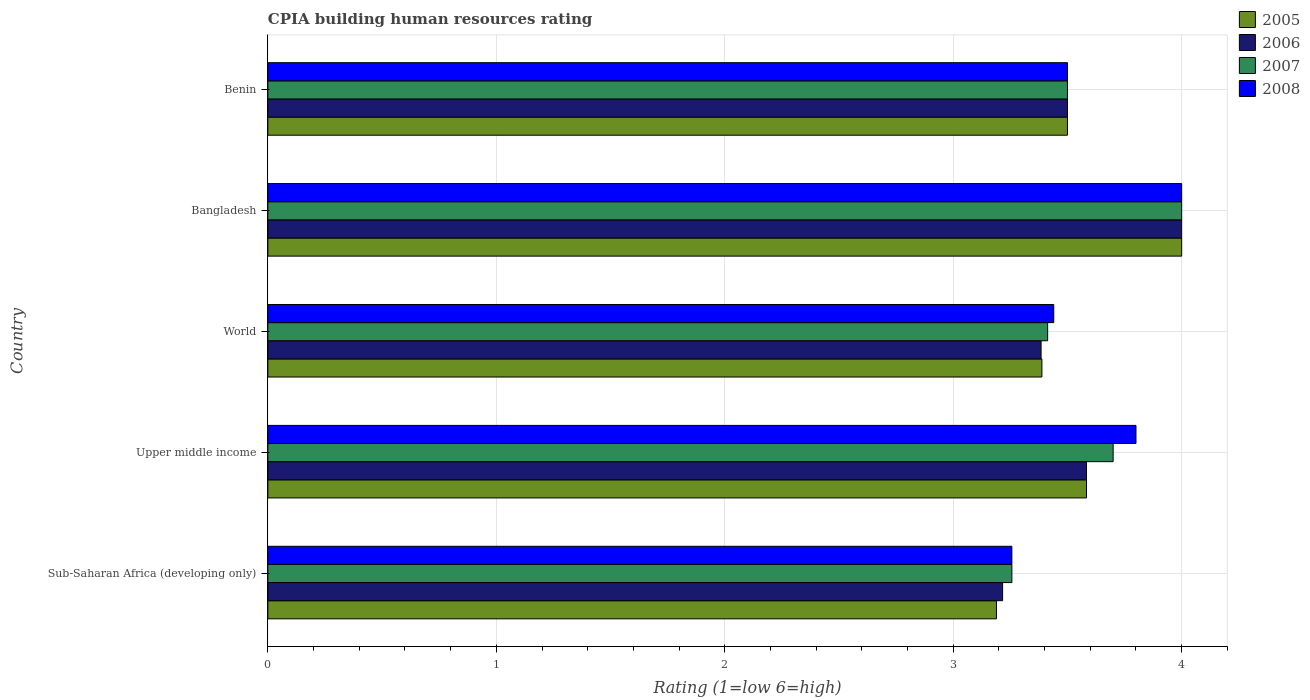How many different coloured bars are there?
Offer a terse response. 4. How many bars are there on the 4th tick from the bottom?
Your answer should be compact. 4. What is the label of the 1st group of bars from the top?
Your answer should be very brief. Benin. In how many cases, is the number of bars for a given country not equal to the number of legend labels?
Your response must be concise. 0. What is the CPIA rating in 2007 in Benin?
Offer a very short reply. 3.5. Across all countries, what is the minimum CPIA rating in 2005?
Keep it short and to the point. 3.19. In which country was the CPIA rating in 2005 maximum?
Your answer should be very brief. Bangladesh. In which country was the CPIA rating in 2008 minimum?
Your response must be concise. Sub-Saharan Africa (developing only). What is the total CPIA rating in 2006 in the graph?
Your answer should be compact. 17.68. What is the difference between the CPIA rating in 2006 in Sub-Saharan Africa (developing only) and that in Upper middle income?
Ensure brevity in your answer.  -0.37. What is the difference between the CPIA rating in 2008 in Bangladesh and the CPIA rating in 2006 in World?
Your answer should be compact. 0.62. What is the average CPIA rating in 2005 per country?
Keep it short and to the point. 3.53. What is the difference between the CPIA rating in 2005 and CPIA rating in 2006 in World?
Provide a succinct answer. 0. In how many countries, is the CPIA rating in 2006 greater than 2.8 ?
Ensure brevity in your answer.  5. What is the ratio of the CPIA rating in 2005 in Sub-Saharan Africa (developing only) to that in Upper middle income?
Your answer should be very brief. 0.89. Is the CPIA rating in 2005 in Benin less than that in Upper middle income?
Ensure brevity in your answer.  Yes. Is the difference between the CPIA rating in 2005 in Bangladesh and Benin greater than the difference between the CPIA rating in 2006 in Bangladesh and Benin?
Your answer should be very brief. No. What is the difference between the highest and the second highest CPIA rating in 2006?
Make the answer very short. 0.42. What is the difference between the highest and the lowest CPIA rating in 2007?
Offer a very short reply. 0.74. In how many countries, is the CPIA rating in 2005 greater than the average CPIA rating in 2005 taken over all countries?
Offer a very short reply. 2. Is the sum of the CPIA rating in 2005 in Bangladesh and Benin greater than the maximum CPIA rating in 2008 across all countries?
Give a very brief answer. Yes. Is it the case that in every country, the sum of the CPIA rating in 2005 and CPIA rating in 2006 is greater than the sum of CPIA rating in 2007 and CPIA rating in 2008?
Offer a terse response. No. What does the 4th bar from the bottom in Upper middle income represents?
Your answer should be very brief. 2008. What is the difference between two consecutive major ticks on the X-axis?
Ensure brevity in your answer.  1. Where does the legend appear in the graph?
Keep it short and to the point. Top right. How many legend labels are there?
Give a very brief answer. 4. How are the legend labels stacked?
Offer a terse response. Vertical. What is the title of the graph?
Provide a short and direct response. CPIA building human resources rating. Does "2013" appear as one of the legend labels in the graph?
Give a very brief answer. No. What is the label or title of the Y-axis?
Ensure brevity in your answer.  Country. What is the Rating (1=low 6=high) of 2005 in Sub-Saharan Africa (developing only)?
Your response must be concise. 3.19. What is the Rating (1=low 6=high) of 2006 in Sub-Saharan Africa (developing only)?
Keep it short and to the point. 3.22. What is the Rating (1=low 6=high) in 2007 in Sub-Saharan Africa (developing only)?
Your answer should be very brief. 3.26. What is the Rating (1=low 6=high) in 2008 in Sub-Saharan Africa (developing only)?
Provide a short and direct response. 3.26. What is the Rating (1=low 6=high) in 2005 in Upper middle income?
Ensure brevity in your answer.  3.58. What is the Rating (1=low 6=high) in 2006 in Upper middle income?
Ensure brevity in your answer.  3.58. What is the Rating (1=low 6=high) in 2007 in Upper middle income?
Ensure brevity in your answer.  3.7. What is the Rating (1=low 6=high) of 2008 in Upper middle income?
Your answer should be very brief. 3.8. What is the Rating (1=low 6=high) of 2005 in World?
Offer a very short reply. 3.39. What is the Rating (1=low 6=high) in 2006 in World?
Keep it short and to the point. 3.38. What is the Rating (1=low 6=high) of 2007 in World?
Offer a terse response. 3.41. What is the Rating (1=low 6=high) in 2008 in World?
Provide a short and direct response. 3.44. What is the Rating (1=low 6=high) in 2006 in Bangladesh?
Offer a very short reply. 4. What is the Rating (1=low 6=high) of 2007 in Bangladesh?
Your answer should be compact. 4. What is the Rating (1=low 6=high) in 2007 in Benin?
Your answer should be very brief. 3.5. What is the Rating (1=low 6=high) of 2008 in Benin?
Offer a terse response. 3.5. Across all countries, what is the maximum Rating (1=low 6=high) in 2006?
Your answer should be compact. 4. Across all countries, what is the maximum Rating (1=low 6=high) in 2007?
Your answer should be very brief. 4. Across all countries, what is the minimum Rating (1=low 6=high) in 2005?
Your answer should be compact. 3.19. Across all countries, what is the minimum Rating (1=low 6=high) in 2006?
Offer a very short reply. 3.22. Across all countries, what is the minimum Rating (1=low 6=high) in 2007?
Your answer should be compact. 3.26. Across all countries, what is the minimum Rating (1=low 6=high) of 2008?
Your answer should be very brief. 3.26. What is the total Rating (1=low 6=high) in 2005 in the graph?
Your answer should be very brief. 17.66. What is the total Rating (1=low 6=high) in 2006 in the graph?
Your answer should be very brief. 17.68. What is the total Rating (1=low 6=high) in 2007 in the graph?
Give a very brief answer. 17.87. What is the total Rating (1=low 6=high) of 2008 in the graph?
Give a very brief answer. 18. What is the difference between the Rating (1=low 6=high) in 2005 in Sub-Saharan Africa (developing only) and that in Upper middle income?
Your response must be concise. -0.39. What is the difference between the Rating (1=low 6=high) in 2006 in Sub-Saharan Africa (developing only) and that in Upper middle income?
Ensure brevity in your answer.  -0.37. What is the difference between the Rating (1=low 6=high) of 2007 in Sub-Saharan Africa (developing only) and that in Upper middle income?
Give a very brief answer. -0.44. What is the difference between the Rating (1=low 6=high) in 2008 in Sub-Saharan Africa (developing only) and that in Upper middle income?
Provide a short and direct response. -0.54. What is the difference between the Rating (1=low 6=high) of 2005 in Sub-Saharan Africa (developing only) and that in World?
Keep it short and to the point. -0.2. What is the difference between the Rating (1=low 6=high) in 2006 in Sub-Saharan Africa (developing only) and that in World?
Give a very brief answer. -0.17. What is the difference between the Rating (1=low 6=high) in 2007 in Sub-Saharan Africa (developing only) and that in World?
Make the answer very short. -0.16. What is the difference between the Rating (1=low 6=high) in 2008 in Sub-Saharan Africa (developing only) and that in World?
Offer a very short reply. -0.18. What is the difference between the Rating (1=low 6=high) of 2005 in Sub-Saharan Africa (developing only) and that in Bangladesh?
Make the answer very short. -0.81. What is the difference between the Rating (1=low 6=high) of 2006 in Sub-Saharan Africa (developing only) and that in Bangladesh?
Keep it short and to the point. -0.78. What is the difference between the Rating (1=low 6=high) of 2007 in Sub-Saharan Africa (developing only) and that in Bangladesh?
Your answer should be compact. -0.74. What is the difference between the Rating (1=low 6=high) in 2008 in Sub-Saharan Africa (developing only) and that in Bangladesh?
Provide a succinct answer. -0.74. What is the difference between the Rating (1=low 6=high) in 2005 in Sub-Saharan Africa (developing only) and that in Benin?
Offer a very short reply. -0.31. What is the difference between the Rating (1=low 6=high) of 2006 in Sub-Saharan Africa (developing only) and that in Benin?
Offer a very short reply. -0.28. What is the difference between the Rating (1=low 6=high) in 2007 in Sub-Saharan Africa (developing only) and that in Benin?
Your response must be concise. -0.24. What is the difference between the Rating (1=low 6=high) of 2008 in Sub-Saharan Africa (developing only) and that in Benin?
Your answer should be very brief. -0.24. What is the difference between the Rating (1=low 6=high) in 2005 in Upper middle income and that in World?
Your answer should be compact. 0.2. What is the difference between the Rating (1=low 6=high) of 2006 in Upper middle income and that in World?
Make the answer very short. 0.2. What is the difference between the Rating (1=low 6=high) of 2007 in Upper middle income and that in World?
Keep it short and to the point. 0.29. What is the difference between the Rating (1=low 6=high) in 2008 in Upper middle income and that in World?
Offer a terse response. 0.36. What is the difference between the Rating (1=low 6=high) of 2005 in Upper middle income and that in Bangladesh?
Offer a terse response. -0.42. What is the difference between the Rating (1=low 6=high) of 2006 in Upper middle income and that in Bangladesh?
Offer a very short reply. -0.42. What is the difference between the Rating (1=low 6=high) in 2008 in Upper middle income and that in Bangladesh?
Your answer should be very brief. -0.2. What is the difference between the Rating (1=low 6=high) in 2005 in Upper middle income and that in Benin?
Provide a short and direct response. 0.08. What is the difference between the Rating (1=low 6=high) in 2006 in Upper middle income and that in Benin?
Provide a short and direct response. 0.08. What is the difference between the Rating (1=low 6=high) in 2007 in Upper middle income and that in Benin?
Make the answer very short. 0.2. What is the difference between the Rating (1=low 6=high) in 2005 in World and that in Bangladesh?
Provide a short and direct response. -0.61. What is the difference between the Rating (1=low 6=high) of 2006 in World and that in Bangladesh?
Provide a short and direct response. -0.62. What is the difference between the Rating (1=low 6=high) in 2007 in World and that in Bangladesh?
Your answer should be compact. -0.59. What is the difference between the Rating (1=low 6=high) of 2008 in World and that in Bangladesh?
Your response must be concise. -0.56. What is the difference between the Rating (1=low 6=high) in 2005 in World and that in Benin?
Make the answer very short. -0.11. What is the difference between the Rating (1=low 6=high) of 2006 in World and that in Benin?
Your answer should be very brief. -0.12. What is the difference between the Rating (1=low 6=high) in 2007 in World and that in Benin?
Make the answer very short. -0.09. What is the difference between the Rating (1=low 6=high) of 2008 in World and that in Benin?
Offer a very short reply. -0.06. What is the difference between the Rating (1=low 6=high) of 2005 in Bangladesh and that in Benin?
Offer a terse response. 0.5. What is the difference between the Rating (1=low 6=high) in 2007 in Bangladesh and that in Benin?
Your answer should be very brief. 0.5. What is the difference between the Rating (1=low 6=high) of 2005 in Sub-Saharan Africa (developing only) and the Rating (1=low 6=high) of 2006 in Upper middle income?
Your response must be concise. -0.39. What is the difference between the Rating (1=low 6=high) in 2005 in Sub-Saharan Africa (developing only) and the Rating (1=low 6=high) in 2007 in Upper middle income?
Keep it short and to the point. -0.51. What is the difference between the Rating (1=low 6=high) in 2005 in Sub-Saharan Africa (developing only) and the Rating (1=low 6=high) in 2008 in Upper middle income?
Provide a succinct answer. -0.61. What is the difference between the Rating (1=low 6=high) in 2006 in Sub-Saharan Africa (developing only) and the Rating (1=low 6=high) in 2007 in Upper middle income?
Provide a short and direct response. -0.48. What is the difference between the Rating (1=low 6=high) in 2006 in Sub-Saharan Africa (developing only) and the Rating (1=low 6=high) in 2008 in Upper middle income?
Keep it short and to the point. -0.58. What is the difference between the Rating (1=low 6=high) in 2007 in Sub-Saharan Africa (developing only) and the Rating (1=low 6=high) in 2008 in Upper middle income?
Offer a very short reply. -0.54. What is the difference between the Rating (1=low 6=high) in 2005 in Sub-Saharan Africa (developing only) and the Rating (1=low 6=high) in 2006 in World?
Your answer should be compact. -0.2. What is the difference between the Rating (1=low 6=high) of 2005 in Sub-Saharan Africa (developing only) and the Rating (1=low 6=high) of 2007 in World?
Your answer should be very brief. -0.22. What is the difference between the Rating (1=low 6=high) in 2005 in Sub-Saharan Africa (developing only) and the Rating (1=low 6=high) in 2008 in World?
Provide a succinct answer. -0.25. What is the difference between the Rating (1=low 6=high) of 2006 in Sub-Saharan Africa (developing only) and the Rating (1=low 6=high) of 2007 in World?
Provide a short and direct response. -0.2. What is the difference between the Rating (1=low 6=high) of 2006 in Sub-Saharan Africa (developing only) and the Rating (1=low 6=high) of 2008 in World?
Your answer should be compact. -0.22. What is the difference between the Rating (1=low 6=high) in 2007 in Sub-Saharan Africa (developing only) and the Rating (1=low 6=high) in 2008 in World?
Provide a short and direct response. -0.18. What is the difference between the Rating (1=low 6=high) in 2005 in Sub-Saharan Africa (developing only) and the Rating (1=low 6=high) in 2006 in Bangladesh?
Offer a very short reply. -0.81. What is the difference between the Rating (1=low 6=high) in 2005 in Sub-Saharan Africa (developing only) and the Rating (1=low 6=high) in 2007 in Bangladesh?
Offer a terse response. -0.81. What is the difference between the Rating (1=low 6=high) of 2005 in Sub-Saharan Africa (developing only) and the Rating (1=low 6=high) of 2008 in Bangladesh?
Provide a succinct answer. -0.81. What is the difference between the Rating (1=low 6=high) of 2006 in Sub-Saharan Africa (developing only) and the Rating (1=low 6=high) of 2007 in Bangladesh?
Your answer should be compact. -0.78. What is the difference between the Rating (1=low 6=high) in 2006 in Sub-Saharan Africa (developing only) and the Rating (1=low 6=high) in 2008 in Bangladesh?
Give a very brief answer. -0.78. What is the difference between the Rating (1=low 6=high) in 2007 in Sub-Saharan Africa (developing only) and the Rating (1=low 6=high) in 2008 in Bangladesh?
Provide a succinct answer. -0.74. What is the difference between the Rating (1=low 6=high) in 2005 in Sub-Saharan Africa (developing only) and the Rating (1=low 6=high) in 2006 in Benin?
Ensure brevity in your answer.  -0.31. What is the difference between the Rating (1=low 6=high) of 2005 in Sub-Saharan Africa (developing only) and the Rating (1=low 6=high) of 2007 in Benin?
Your response must be concise. -0.31. What is the difference between the Rating (1=low 6=high) of 2005 in Sub-Saharan Africa (developing only) and the Rating (1=low 6=high) of 2008 in Benin?
Provide a short and direct response. -0.31. What is the difference between the Rating (1=low 6=high) in 2006 in Sub-Saharan Africa (developing only) and the Rating (1=low 6=high) in 2007 in Benin?
Offer a very short reply. -0.28. What is the difference between the Rating (1=low 6=high) in 2006 in Sub-Saharan Africa (developing only) and the Rating (1=low 6=high) in 2008 in Benin?
Make the answer very short. -0.28. What is the difference between the Rating (1=low 6=high) in 2007 in Sub-Saharan Africa (developing only) and the Rating (1=low 6=high) in 2008 in Benin?
Ensure brevity in your answer.  -0.24. What is the difference between the Rating (1=low 6=high) in 2005 in Upper middle income and the Rating (1=low 6=high) in 2006 in World?
Provide a short and direct response. 0.2. What is the difference between the Rating (1=low 6=high) in 2005 in Upper middle income and the Rating (1=low 6=high) in 2007 in World?
Provide a short and direct response. 0.17. What is the difference between the Rating (1=low 6=high) of 2005 in Upper middle income and the Rating (1=low 6=high) of 2008 in World?
Offer a terse response. 0.14. What is the difference between the Rating (1=low 6=high) in 2006 in Upper middle income and the Rating (1=low 6=high) in 2007 in World?
Offer a terse response. 0.17. What is the difference between the Rating (1=low 6=high) in 2006 in Upper middle income and the Rating (1=low 6=high) in 2008 in World?
Ensure brevity in your answer.  0.14. What is the difference between the Rating (1=low 6=high) of 2007 in Upper middle income and the Rating (1=low 6=high) of 2008 in World?
Provide a succinct answer. 0.26. What is the difference between the Rating (1=low 6=high) of 2005 in Upper middle income and the Rating (1=low 6=high) of 2006 in Bangladesh?
Your response must be concise. -0.42. What is the difference between the Rating (1=low 6=high) in 2005 in Upper middle income and the Rating (1=low 6=high) in 2007 in Bangladesh?
Your answer should be very brief. -0.42. What is the difference between the Rating (1=low 6=high) in 2005 in Upper middle income and the Rating (1=low 6=high) in 2008 in Bangladesh?
Your response must be concise. -0.42. What is the difference between the Rating (1=low 6=high) of 2006 in Upper middle income and the Rating (1=low 6=high) of 2007 in Bangladesh?
Your response must be concise. -0.42. What is the difference between the Rating (1=low 6=high) in 2006 in Upper middle income and the Rating (1=low 6=high) in 2008 in Bangladesh?
Keep it short and to the point. -0.42. What is the difference between the Rating (1=low 6=high) in 2007 in Upper middle income and the Rating (1=low 6=high) in 2008 in Bangladesh?
Your response must be concise. -0.3. What is the difference between the Rating (1=low 6=high) of 2005 in Upper middle income and the Rating (1=low 6=high) of 2006 in Benin?
Your answer should be compact. 0.08. What is the difference between the Rating (1=low 6=high) of 2005 in Upper middle income and the Rating (1=low 6=high) of 2007 in Benin?
Give a very brief answer. 0.08. What is the difference between the Rating (1=low 6=high) of 2005 in Upper middle income and the Rating (1=low 6=high) of 2008 in Benin?
Offer a very short reply. 0.08. What is the difference between the Rating (1=low 6=high) of 2006 in Upper middle income and the Rating (1=low 6=high) of 2007 in Benin?
Your answer should be very brief. 0.08. What is the difference between the Rating (1=low 6=high) in 2006 in Upper middle income and the Rating (1=low 6=high) in 2008 in Benin?
Provide a succinct answer. 0.08. What is the difference between the Rating (1=low 6=high) in 2005 in World and the Rating (1=low 6=high) in 2006 in Bangladesh?
Your answer should be compact. -0.61. What is the difference between the Rating (1=low 6=high) in 2005 in World and the Rating (1=low 6=high) in 2007 in Bangladesh?
Offer a terse response. -0.61. What is the difference between the Rating (1=low 6=high) of 2005 in World and the Rating (1=low 6=high) of 2008 in Bangladesh?
Provide a short and direct response. -0.61. What is the difference between the Rating (1=low 6=high) of 2006 in World and the Rating (1=low 6=high) of 2007 in Bangladesh?
Provide a succinct answer. -0.62. What is the difference between the Rating (1=low 6=high) in 2006 in World and the Rating (1=low 6=high) in 2008 in Bangladesh?
Provide a short and direct response. -0.62. What is the difference between the Rating (1=low 6=high) in 2007 in World and the Rating (1=low 6=high) in 2008 in Bangladesh?
Keep it short and to the point. -0.59. What is the difference between the Rating (1=low 6=high) of 2005 in World and the Rating (1=low 6=high) of 2006 in Benin?
Your answer should be compact. -0.11. What is the difference between the Rating (1=low 6=high) of 2005 in World and the Rating (1=low 6=high) of 2007 in Benin?
Your response must be concise. -0.11. What is the difference between the Rating (1=low 6=high) of 2005 in World and the Rating (1=low 6=high) of 2008 in Benin?
Offer a very short reply. -0.11. What is the difference between the Rating (1=low 6=high) in 2006 in World and the Rating (1=low 6=high) in 2007 in Benin?
Your answer should be compact. -0.12. What is the difference between the Rating (1=low 6=high) of 2006 in World and the Rating (1=low 6=high) of 2008 in Benin?
Your answer should be very brief. -0.12. What is the difference between the Rating (1=low 6=high) in 2007 in World and the Rating (1=low 6=high) in 2008 in Benin?
Offer a terse response. -0.09. What is the difference between the Rating (1=low 6=high) of 2005 in Bangladesh and the Rating (1=low 6=high) of 2006 in Benin?
Provide a succinct answer. 0.5. What is the difference between the Rating (1=low 6=high) of 2005 in Bangladesh and the Rating (1=low 6=high) of 2007 in Benin?
Your answer should be compact. 0.5. What is the difference between the Rating (1=low 6=high) of 2006 in Bangladesh and the Rating (1=low 6=high) of 2008 in Benin?
Make the answer very short. 0.5. What is the average Rating (1=low 6=high) of 2005 per country?
Ensure brevity in your answer.  3.53. What is the average Rating (1=low 6=high) in 2006 per country?
Ensure brevity in your answer.  3.54. What is the average Rating (1=low 6=high) of 2007 per country?
Your answer should be compact. 3.57. What is the average Rating (1=low 6=high) of 2008 per country?
Your answer should be very brief. 3.6. What is the difference between the Rating (1=low 6=high) of 2005 and Rating (1=low 6=high) of 2006 in Sub-Saharan Africa (developing only)?
Make the answer very short. -0.03. What is the difference between the Rating (1=low 6=high) in 2005 and Rating (1=low 6=high) in 2007 in Sub-Saharan Africa (developing only)?
Provide a succinct answer. -0.07. What is the difference between the Rating (1=low 6=high) of 2005 and Rating (1=low 6=high) of 2008 in Sub-Saharan Africa (developing only)?
Keep it short and to the point. -0.07. What is the difference between the Rating (1=low 6=high) in 2006 and Rating (1=low 6=high) in 2007 in Sub-Saharan Africa (developing only)?
Make the answer very short. -0.04. What is the difference between the Rating (1=low 6=high) in 2006 and Rating (1=low 6=high) in 2008 in Sub-Saharan Africa (developing only)?
Ensure brevity in your answer.  -0.04. What is the difference between the Rating (1=low 6=high) in 2005 and Rating (1=low 6=high) in 2007 in Upper middle income?
Keep it short and to the point. -0.12. What is the difference between the Rating (1=low 6=high) in 2005 and Rating (1=low 6=high) in 2008 in Upper middle income?
Provide a succinct answer. -0.22. What is the difference between the Rating (1=low 6=high) of 2006 and Rating (1=low 6=high) of 2007 in Upper middle income?
Offer a very short reply. -0.12. What is the difference between the Rating (1=low 6=high) in 2006 and Rating (1=low 6=high) in 2008 in Upper middle income?
Offer a terse response. -0.22. What is the difference between the Rating (1=low 6=high) of 2007 and Rating (1=low 6=high) of 2008 in Upper middle income?
Make the answer very short. -0.1. What is the difference between the Rating (1=low 6=high) of 2005 and Rating (1=low 6=high) of 2006 in World?
Keep it short and to the point. 0. What is the difference between the Rating (1=low 6=high) of 2005 and Rating (1=low 6=high) of 2007 in World?
Keep it short and to the point. -0.03. What is the difference between the Rating (1=low 6=high) in 2005 and Rating (1=low 6=high) in 2008 in World?
Provide a short and direct response. -0.05. What is the difference between the Rating (1=low 6=high) of 2006 and Rating (1=low 6=high) of 2007 in World?
Ensure brevity in your answer.  -0.03. What is the difference between the Rating (1=low 6=high) of 2006 and Rating (1=low 6=high) of 2008 in World?
Your answer should be compact. -0.06. What is the difference between the Rating (1=low 6=high) of 2007 and Rating (1=low 6=high) of 2008 in World?
Provide a short and direct response. -0.03. What is the difference between the Rating (1=low 6=high) of 2005 and Rating (1=low 6=high) of 2008 in Bangladesh?
Provide a succinct answer. 0. What is the difference between the Rating (1=low 6=high) of 2006 and Rating (1=low 6=high) of 2007 in Bangladesh?
Your response must be concise. 0. What is the difference between the Rating (1=low 6=high) of 2005 and Rating (1=low 6=high) of 2006 in Benin?
Ensure brevity in your answer.  0. What is the difference between the Rating (1=low 6=high) of 2005 and Rating (1=low 6=high) of 2007 in Benin?
Ensure brevity in your answer.  0. What is the difference between the Rating (1=low 6=high) of 2007 and Rating (1=low 6=high) of 2008 in Benin?
Your answer should be compact. 0. What is the ratio of the Rating (1=low 6=high) of 2005 in Sub-Saharan Africa (developing only) to that in Upper middle income?
Your response must be concise. 0.89. What is the ratio of the Rating (1=low 6=high) in 2006 in Sub-Saharan Africa (developing only) to that in Upper middle income?
Make the answer very short. 0.9. What is the ratio of the Rating (1=low 6=high) in 2007 in Sub-Saharan Africa (developing only) to that in Upper middle income?
Provide a short and direct response. 0.88. What is the ratio of the Rating (1=low 6=high) in 2008 in Sub-Saharan Africa (developing only) to that in Upper middle income?
Offer a terse response. 0.86. What is the ratio of the Rating (1=low 6=high) in 2005 in Sub-Saharan Africa (developing only) to that in World?
Your response must be concise. 0.94. What is the ratio of the Rating (1=low 6=high) in 2006 in Sub-Saharan Africa (developing only) to that in World?
Offer a terse response. 0.95. What is the ratio of the Rating (1=low 6=high) in 2007 in Sub-Saharan Africa (developing only) to that in World?
Give a very brief answer. 0.95. What is the ratio of the Rating (1=low 6=high) in 2008 in Sub-Saharan Africa (developing only) to that in World?
Offer a very short reply. 0.95. What is the ratio of the Rating (1=low 6=high) of 2005 in Sub-Saharan Africa (developing only) to that in Bangladesh?
Offer a very short reply. 0.8. What is the ratio of the Rating (1=low 6=high) of 2006 in Sub-Saharan Africa (developing only) to that in Bangladesh?
Offer a terse response. 0.8. What is the ratio of the Rating (1=low 6=high) in 2007 in Sub-Saharan Africa (developing only) to that in Bangladesh?
Offer a terse response. 0.81. What is the ratio of the Rating (1=low 6=high) of 2008 in Sub-Saharan Africa (developing only) to that in Bangladesh?
Give a very brief answer. 0.81. What is the ratio of the Rating (1=low 6=high) in 2005 in Sub-Saharan Africa (developing only) to that in Benin?
Ensure brevity in your answer.  0.91. What is the ratio of the Rating (1=low 6=high) of 2006 in Sub-Saharan Africa (developing only) to that in Benin?
Make the answer very short. 0.92. What is the ratio of the Rating (1=low 6=high) in 2007 in Sub-Saharan Africa (developing only) to that in Benin?
Give a very brief answer. 0.93. What is the ratio of the Rating (1=low 6=high) of 2008 in Sub-Saharan Africa (developing only) to that in Benin?
Provide a succinct answer. 0.93. What is the ratio of the Rating (1=low 6=high) in 2005 in Upper middle income to that in World?
Offer a very short reply. 1.06. What is the ratio of the Rating (1=low 6=high) in 2006 in Upper middle income to that in World?
Provide a short and direct response. 1.06. What is the ratio of the Rating (1=low 6=high) of 2007 in Upper middle income to that in World?
Ensure brevity in your answer.  1.08. What is the ratio of the Rating (1=low 6=high) in 2008 in Upper middle income to that in World?
Give a very brief answer. 1.1. What is the ratio of the Rating (1=low 6=high) of 2005 in Upper middle income to that in Bangladesh?
Make the answer very short. 0.9. What is the ratio of the Rating (1=low 6=high) of 2006 in Upper middle income to that in Bangladesh?
Ensure brevity in your answer.  0.9. What is the ratio of the Rating (1=low 6=high) of 2007 in Upper middle income to that in Bangladesh?
Give a very brief answer. 0.93. What is the ratio of the Rating (1=low 6=high) of 2005 in Upper middle income to that in Benin?
Make the answer very short. 1.02. What is the ratio of the Rating (1=low 6=high) in 2006 in Upper middle income to that in Benin?
Make the answer very short. 1.02. What is the ratio of the Rating (1=low 6=high) in 2007 in Upper middle income to that in Benin?
Keep it short and to the point. 1.06. What is the ratio of the Rating (1=low 6=high) in 2008 in Upper middle income to that in Benin?
Your answer should be very brief. 1.09. What is the ratio of the Rating (1=low 6=high) of 2005 in World to that in Bangladesh?
Offer a very short reply. 0.85. What is the ratio of the Rating (1=low 6=high) in 2006 in World to that in Bangladesh?
Ensure brevity in your answer.  0.85. What is the ratio of the Rating (1=low 6=high) in 2007 in World to that in Bangladesh?
Give a very brief answer. 0.85. What is the ratio of the Rating (1=low 6=high) of 2008 in World to that in Bangladesh?
Give a very brief answer. 0.86. What is the ratio of the Rating (1=low 6=high) in 2005 in World to that in Benin?
Provide a succinct answer. 0.97. What is the ratio of the Rating (1=low 6=high) in 2006 in World to that in Benin?
Your response must be concise. 0.97. What is the ratio of the Rating (1=low 6=high) of 2007 in World to that in Benin?
Make the answer very short. 0.98. What is the ratio of the Rating (1=low 6=high) in 2008 in World to that in Benin?
Make the answer very short. 0.98. What is the ratio of the Rating (1=low 6=high) of 2006 in Bangladesh to that in Benin?
Make the answer very short. 1.14. What is the ratio of the Rating (1=low 6=high) of 2007 in Bangladesh to that in Benin?
Make the answer very short. 1.14. What is the ratio of the Rating (1=low 6=high) of 2008 in Bangladesh to that in Benin?
Offer a terse response. 1.14. What is the difference between the highest and the second highest Rating (1=low 6=high) in 2005?
Provide a succinct answer. 0.42. What is the difference between the highest and the second highest Rating (1=low 6=high) of 2006?
Provide a short and direct response. 0.42. What is the difference between the highest and the second highest Rating (1=low 6=high) in 2007?
Give a very brief answer. 0.3. What is the difference between the highest and the lowest Rating (1=low 6=high) of 2005?
Your response must be concise. 0.81. What is the difference between the highest and the lowest Rating (1=low 6=high) of 2006?
Provide a short and direct response. 0.78. What is the difference between the highest and the lowest Rating (1=low 6=high) in 2007?
Make the answer very short. 0.74. What is the difference between the highest and the lowest Rating (1=low 6=high) in 2008?
Make the answer very short. 0.74. 